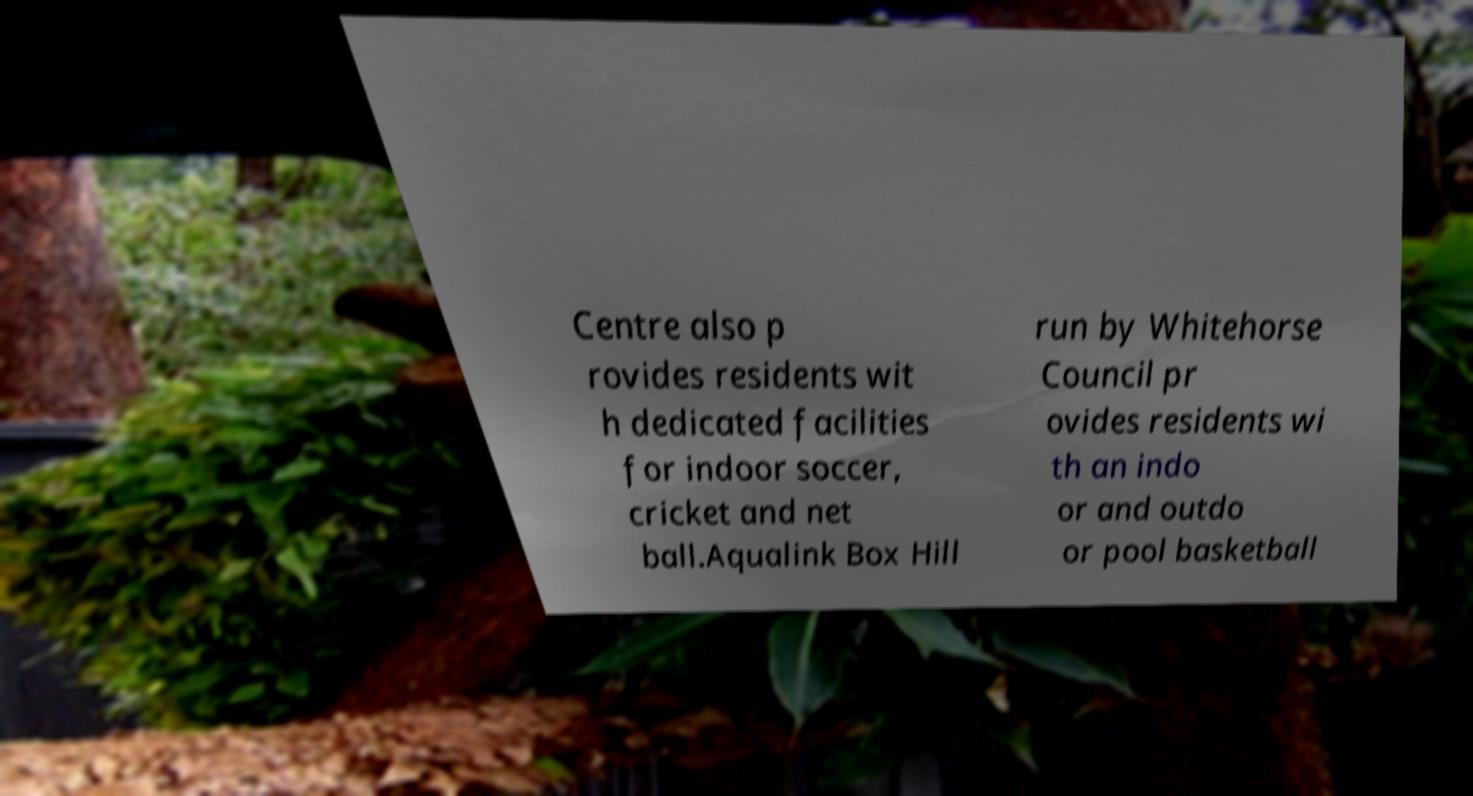For documentation purposes, I need the text within this image transcribed. Could you provide that? Centre also p rovides residents wit h dedicated facilities for indoor soccer, cricket and net ball.Aqualink Box Hill run by Whitehorse Council pr ovides residents wi th an indo or and outdo or pool basketball 